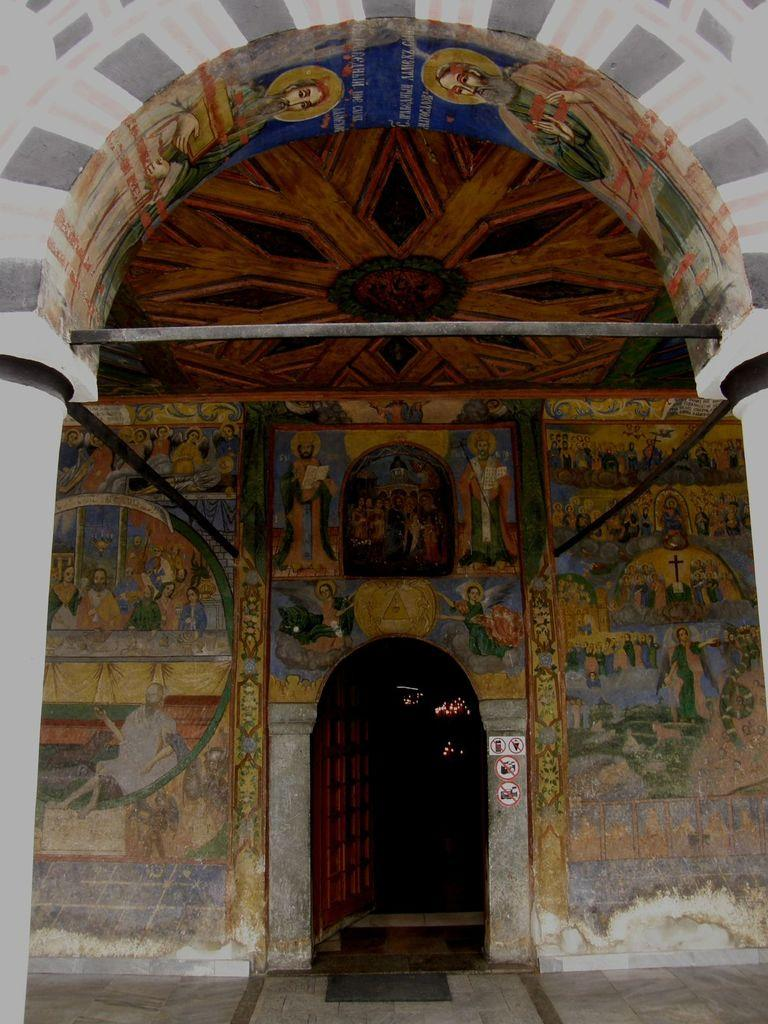What type of structure can be seen in the image? There is a door in the image, which suggests a room or building. What is hanging on the wall in the image? There is a painting on the wall in the image. What part of the room is visible in the image? The ceiling is visible in the image. Can you describe any other objects present in the image? There are other objects present in the image, but their specific details are not mentioned in the provided facts. What type of knowledge is being shared by the governor in the image? There is no governor or knowledge sharing present in the image; it only features a door, a painting, and a visible ceiling. 